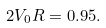<formula> <loc_0><loc_0><loc_500><loc_500>2 V _ { 0 } R = 0 . 9 5 .</formula> 